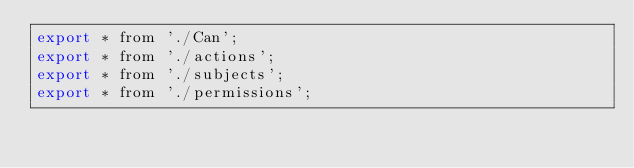<code> <loc_0><loc_0><loc_500><loc_500><_JavaScript_>export * from './Can';
export * from './actions';
export * from './subjects';
export * from './permissions';
</code> 